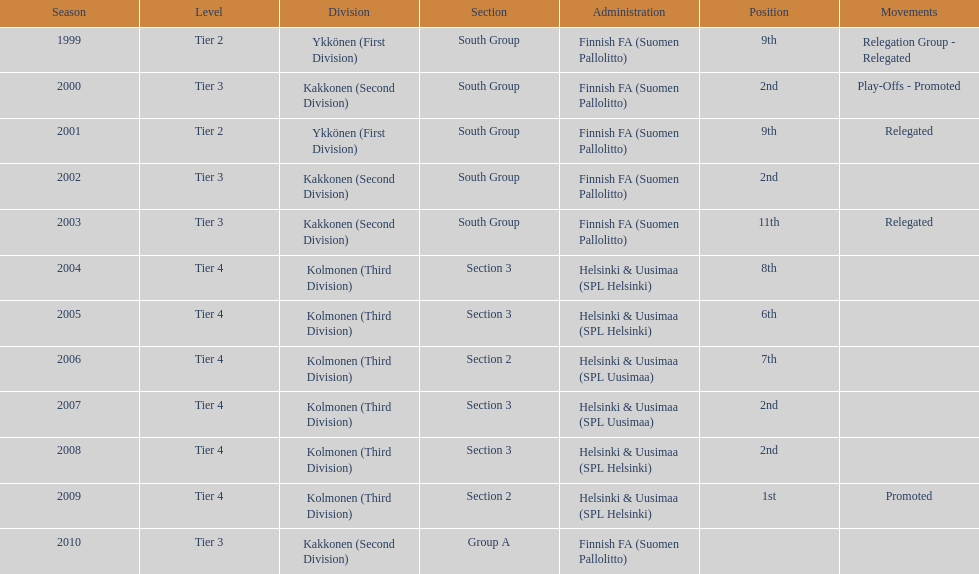What is the first tier listed? Tier 2. 